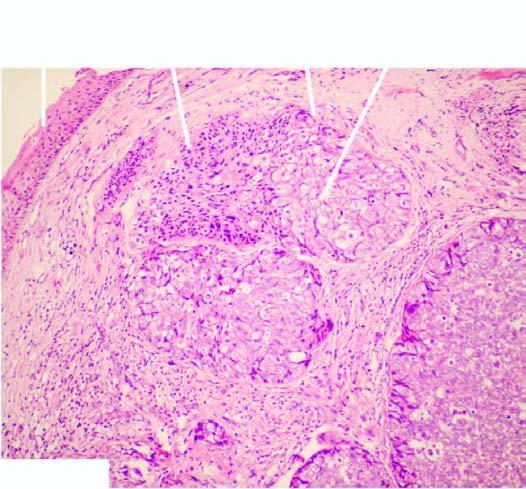what are arranged as lobules with peripheral basaloid cells and pale cells in the centre?
Answer the question using a single word or phrase. Tumour cells 